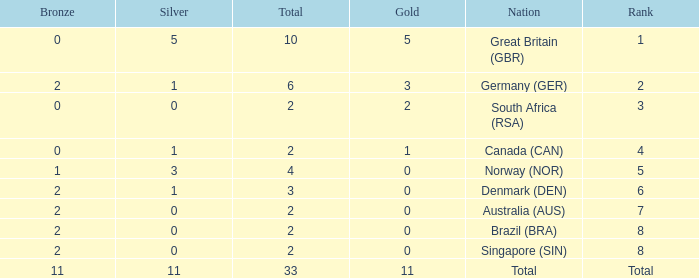What is the total when the nation is brazil (bra) and bronze is more than 2? None. 